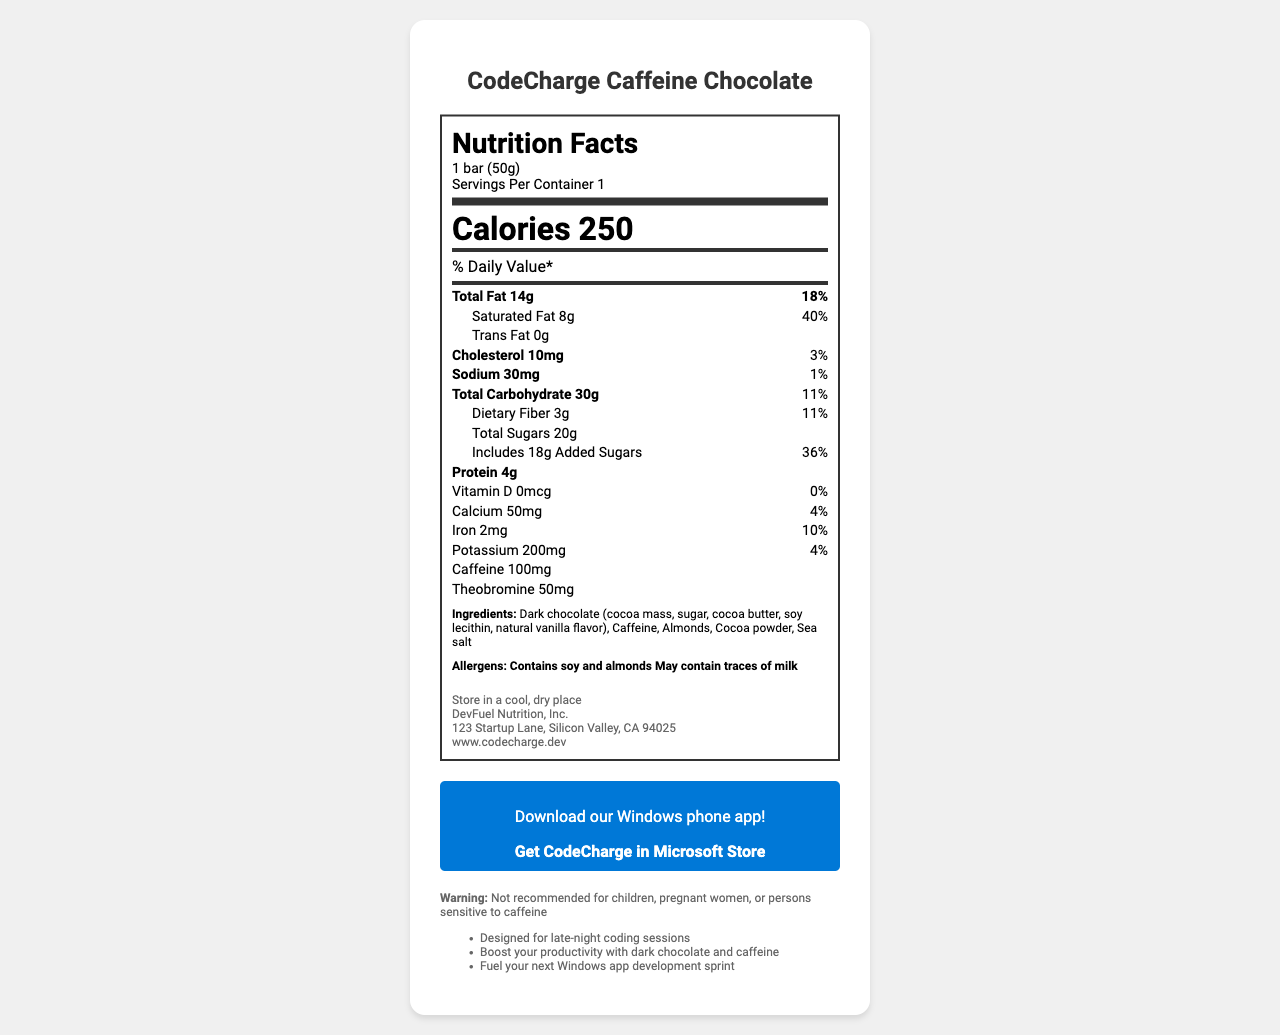what is the serving size of CodeCharge Caffeine Chocolate? The serving size is listed at the top of the nutrition facts box as "1 bar (50g)".
Answer: 1 bar (50g) how many calories are in one serving of CodeCharge Caffeine Chocolate? The calorie content is prominently displayed as "Calories 250" in the middle of the nutrition label.
Answer: 250 what is the total fat content in one serving? The total fat content is shown as "Total Fat 14g" in the nutrition facts section.
Answer: 14g how much caffeine is in the CodeCharge Caffeine Chocolate bar? The amount of caffeine is shown at the bottom of the nutrition facts box as "Caffeine 100mg".
Answer: 100mg how many grams of protein are in the CodeCharge Caffeine Chocolate bar? The protein content is listed in the nutrition facts box as "Protein 4g".
Answer: 4g which of the following is a correct daily value percentage for dietary fiber? A. 5% B. 11% C. 20% D. 25% The dietary fiber daily value is listed as "Dietary Fiber 3g" and its daily value is "11%".
Answer: B what is a marketing claim made about CodeCharge Caffeine Chocolate? A. Promotes weight loss B. Designed for late-night coding sessions C. Enhances muscle growth D. Improves heart health One of the marketing claims listed is "Designed for late-night coding sessions".
Answer: B is this product suitable for children and pregnant women? The warning at the bottom of the document states that it is "Not recommended for children, pregnant women, or persons sensitive to caffeine."
Answer: No how many servings are there in one container? The document states "Servings Per Container 1" in the serving info section.
Answer: 1 what allergens are present in the CodeCharge Caffeine Chocolate bar? The allergens section lists "Contains soy and almonds. May contain traces of milk."
Answer: Contains soy and almonds. May contain traces of milk. summarize the main idea of the document. The document is centered around presenting the nutritional information and unique selling points of CodeCharge Caffeine Chocolate, emphasizing its suitability for programmers and work-related productivity.
Answer: The document provides detailed nutrition facts, ingredients, allergens, and marketing claims for CodeCharge Caffeine Chocolate, a product designed to boost productivity during late-night coding sessions. It highlights its caffeine content, serving size, daily value percentages, and additional product details like manufacturer, storage instructions, and a link to download a related Windows phone app. what is the exact address of the manufacturer? The manufacturer's address is listed under the additional information section as "123 Startup Lane, Silicon Valley, CA 94025".
Answer: 123 Startup Lane, Silicon Valley, CA 94025 how much added sugar does the CodeCharge Caffeine Chocolate contain? The nutrition facts show "Includes 18g Added Sugars".
Answer: 18g what vitamin is completely absent in CodeCharge Caffeine Chocolate? The nutrition facts indicate "Vitamin D 0mcg 0%".
Answer: Vitamin D what is the role of theobromine in the CodeCharge Caffeine Chocolate bar? The document states the amount of theobromine in the bar but does not explain its role or effect.
Answer: Not enough information where should the CodeCharge Caffeine Chocolate be stored? The storage instruction in the document states "Store in a cool, dry place".
Answer: In a cool, dry place 